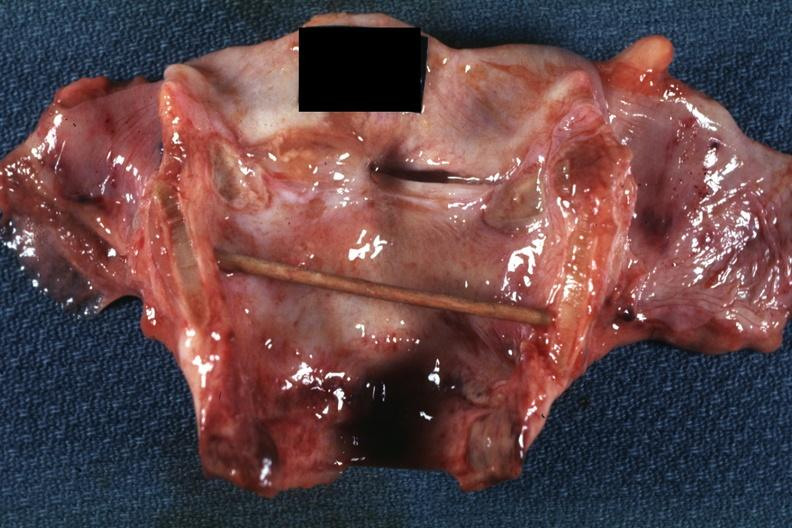what does this image show?
Answer the question using a single word or phrase. Excellent example intubation lesion with tracheitis 